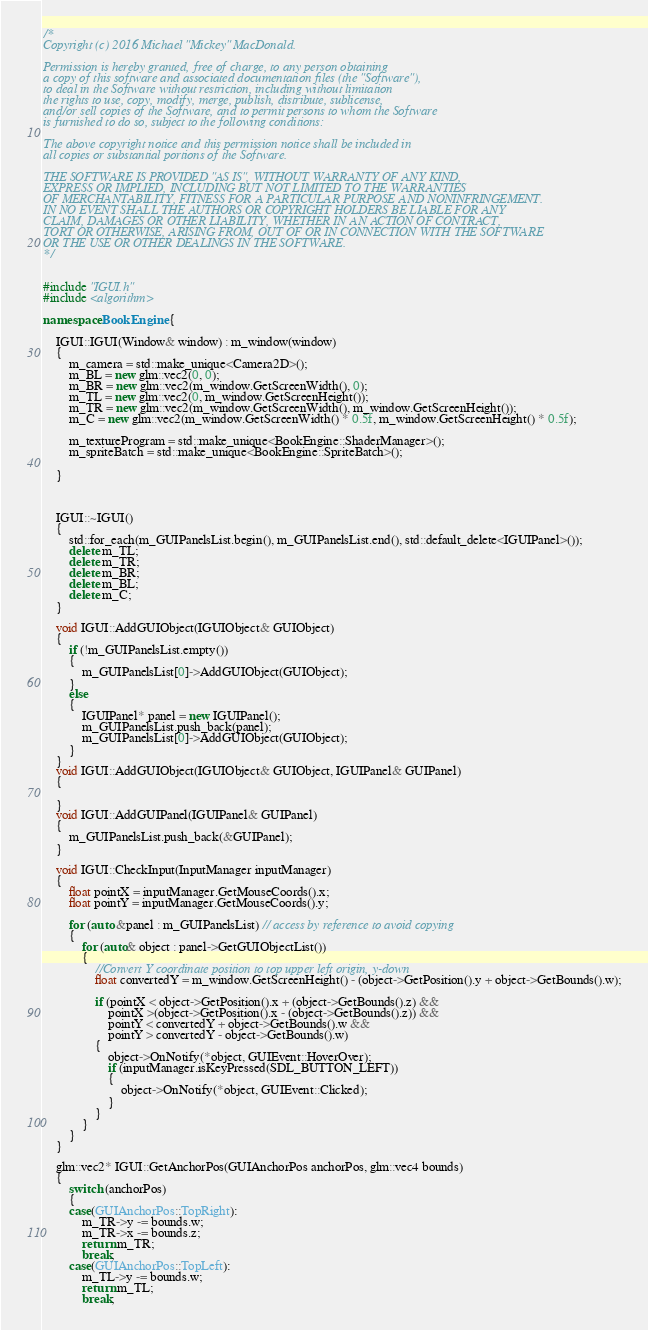<code> <loc_0><loc_0><loc_500><loc_500><_C++_>/*
Copyright (c) 2016 Michael "Mickey" MacDonald.

Permission is hereby granted, free of charge, to any person obtaining
a copy of this software and associated documentation files (the "Software"),
to deal in the Software without restriction, including without limitation
the rights to use, copy, modify, merge, publish, distribute, sublicense,
and/or sell copies of the Software, and to permit persons to whom the Software
is furnished to do so, subject to the following conditions:

The above copyright notice and this permission notice shall be included in
all copies or substantial portions of the Software.

THE SOFTWARE IS PROVIDED "AS IS", WITHOUT WARRANTY OF ANY KIND,
EXPRESS OR IMPLIED, INCLUDING BUT NOT LIMITED TO THE WARRANTIES
OF MERCHANTABILITY, FITNESS FOR A PARTICULAR PURPOSE AND NONINFRINGEMENT.
IN NO EVENT SHALL THE AUTHORS OR COPYRIGHT HOLDERS BE LIABLE FOR ANY
CLAIM, DAMAGES OR OTHER LIABILITY, WHETHER IN AN ACTION OF CONTRACT,
TORT OR OTHERWISE, ARISING FROM, OUT OF OR IN CONNECTION WITH THE SOFTWARE
OR THE USE OR OTHER DEALINGS IN THE SOFTWARE.
*/


#include "IGUI.h"
#include <algorithm>

namespace BookEngine {

	IGUI::IGUI(Window& window) : m_window(window)
	{
		m_camera = std::make_unique<Camera2D>();
		m_BL = new glm::vec2(0, 0);
		m_BR = new glm::vec2(m_window.GetScreenWidth(), 0);
		m_TL = new glm::vec2(0, m_window.GetScreenHeight());
		m_TR = new glm::vec2(m_window.GetScreenWidth(), m_window.GetScreenHeight());
		m_C = new glm::vec2(m_window.GetScreenWidth() * 0.5f, m_window.GetScreenHeight() * 0.5f);

		m_textureProgram = std::make_unique<BookEngine::ShaderManager>();
		m_spriteBatch = std::make_unique<BookEngine::SpriteBatch>();

	}
	


	IGUI::~IGUI()
	{
		std::for_each(m_GUIPanelsList.begin(), m_GUIPanelsList.end(), std::default_delete<IGUIPanel>());
		delete m_TL;
		delete m_TR;
		delete m_BR;
		delete m_BL;
		delete m_C;	
	}

	void IGUI::AddGUIObject(IGUIObject& GUIObject)
	{
		if (!m_GUIPanelsList.empty())
		{
			m_GUIPanelsList[0]->AddGUIObject(GUIObject);
		}
		else
		{
			IGUIPanel* panel = new IGUIPanel();
			m_GUIPanelsList.push_back(panel);
			m_GUIPanelsList[0]->AddGUIObject(GUIObject);
		}
	}
	void IGUI::AddGUIObject(IGUIObject& GUIObject, IGUIPanel& GUIPanel)
	{

	}
	void IGUI::AddGUIPanel(IGUIPanel& GUIPanel)
	{
		m_GUIPanelsList.push_back(&GUIPanel);
	}

	void IGUI::CheckInput(InputManager inputManager)
	{
		float pointX = inputManager.GetMouseCoords().x;
		float pointY = inputManager.GetMouseCoords().y;

		for (auto &panel : m_GUIPanelsList) // access by reference to avoid copying
		{
			for (auto& object : panel->GetGUIObjectList())
			{
				//Convert Y coordinate position to top upper left origin, y-down 
				float convertedY = m_window.GetScreenHeight() - (object->GetPosition().y + object->GetBounds().w);

				if (pointX < object->GetPosition().x + (object->GetBounds().z) &&
					pointX >(object->GetPosition().x - (object->GetBounds().z)) &&
					pointY < convertedY + object->GetBounds().w &&
					pointY > convertedY - object->GetBounds().w)
				{
					object->OnNotify(*object, GUIEvent::HoverOver);
					if (inputManager.isKeyPressed(SDL_BUTTON_LEFT))
					{
						object->OnNotify(*object, GUIEvent::Clicked);
					}
				}
			}
		}
	}

	glm::vec2* IGUI::GetAnchorPos(GUIAnchorPos anchorPos, glm::vec4 bounds)
	{
		switch (anchorPos)
		{
		case(GUIAnchorPos::TopRight):
			m_TR->y -= bounds.w;
			m_TR->x -= bounds.z;
			return m_TR;
			break;
		case(GUIAnchorPos::TopLeft):
			m_TL->y -= bounds.w;
			return m_TL;
			break;</code> 